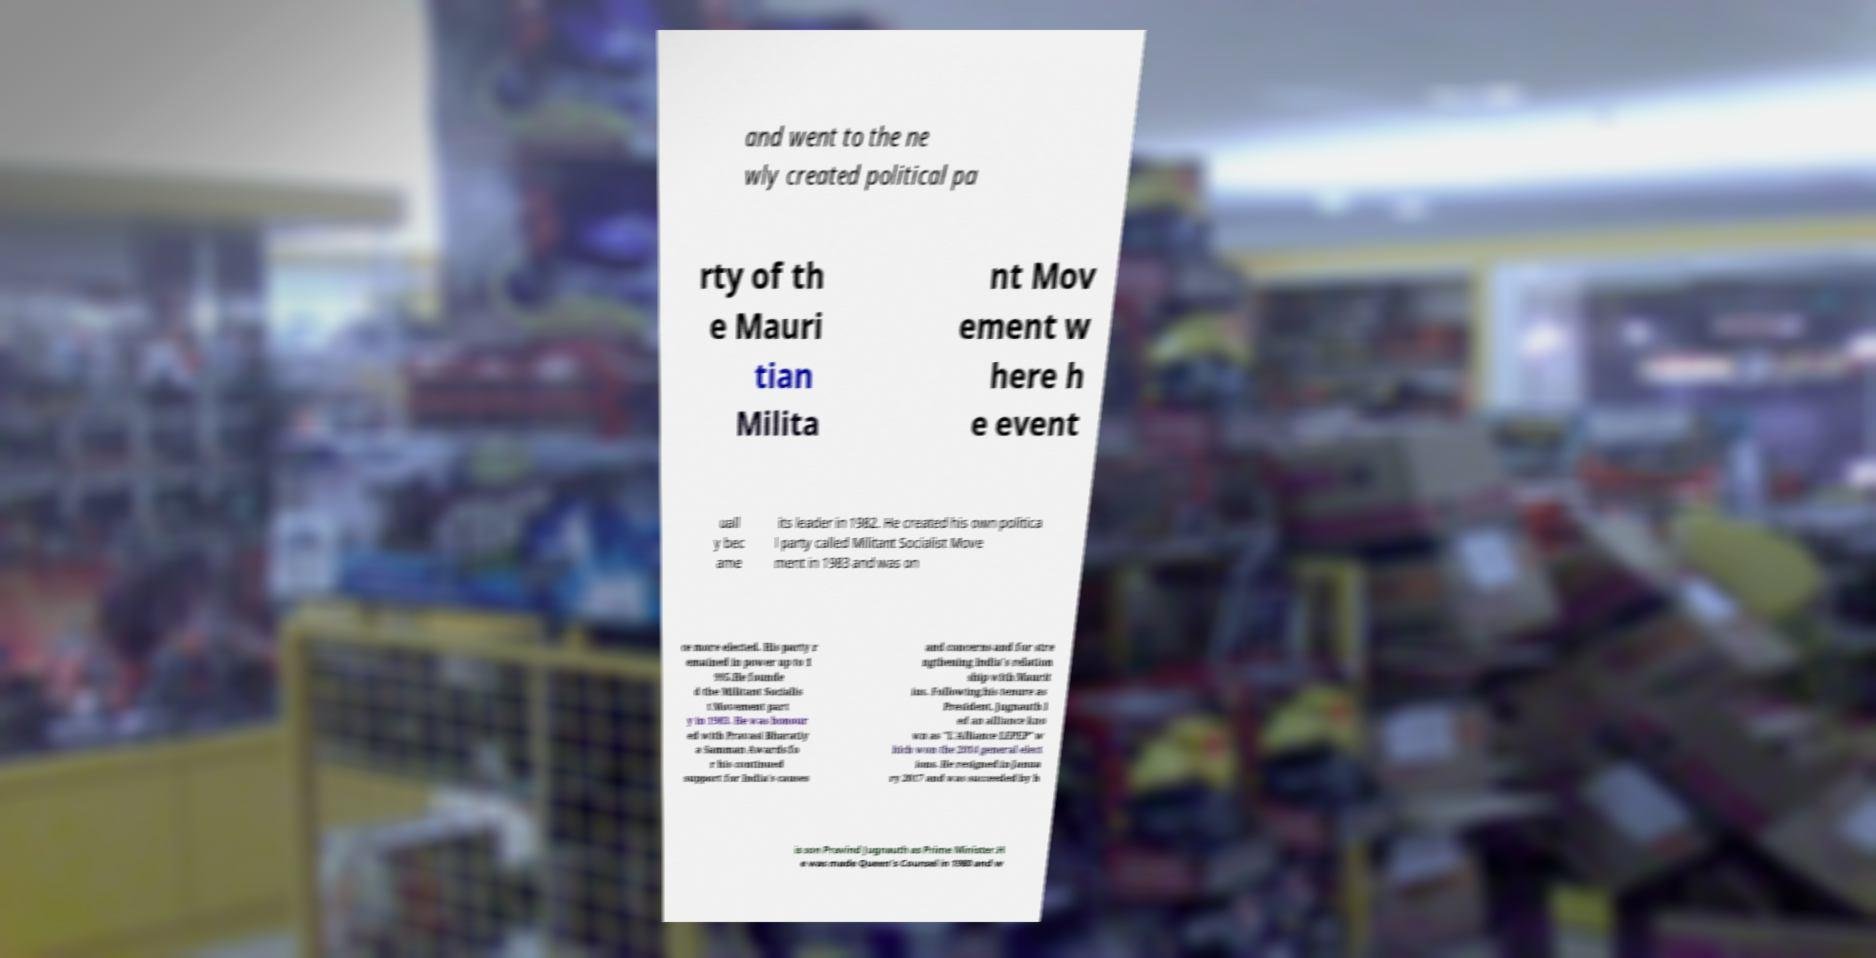Can you read and provide the text displayed in the image?This photo seems to have some interesting text. Can you extract and type it out for me? and went to the ne wly created political pa rty of th e Mauri tian Milita nt Mov ement w here h e event uall y bec ame its leader in 1982. He created his own politica l party called Militant Socialist Move ment in 1983 and was on ce more elected. His party r emained in power up to 1 995.He founde d the Militant Socialis t Movement part y in 1983. He was honour ed with Pravasi Bharatiy a Samman Awards fo r his continued support for India's causes and concerns and for stre ngthening India's relation ship with Maurit ius. Following his tenure as President, Jugnauth l ed an alliance kno wn as "L'Alliance LEPEP" w hich won the 2014 general elect ions. He resigned in Janua ry 2017 and was succeeded by h is son Pravind Jugnauth as Prime Minister.H e was made Queen's Counsel in 1980 and w 